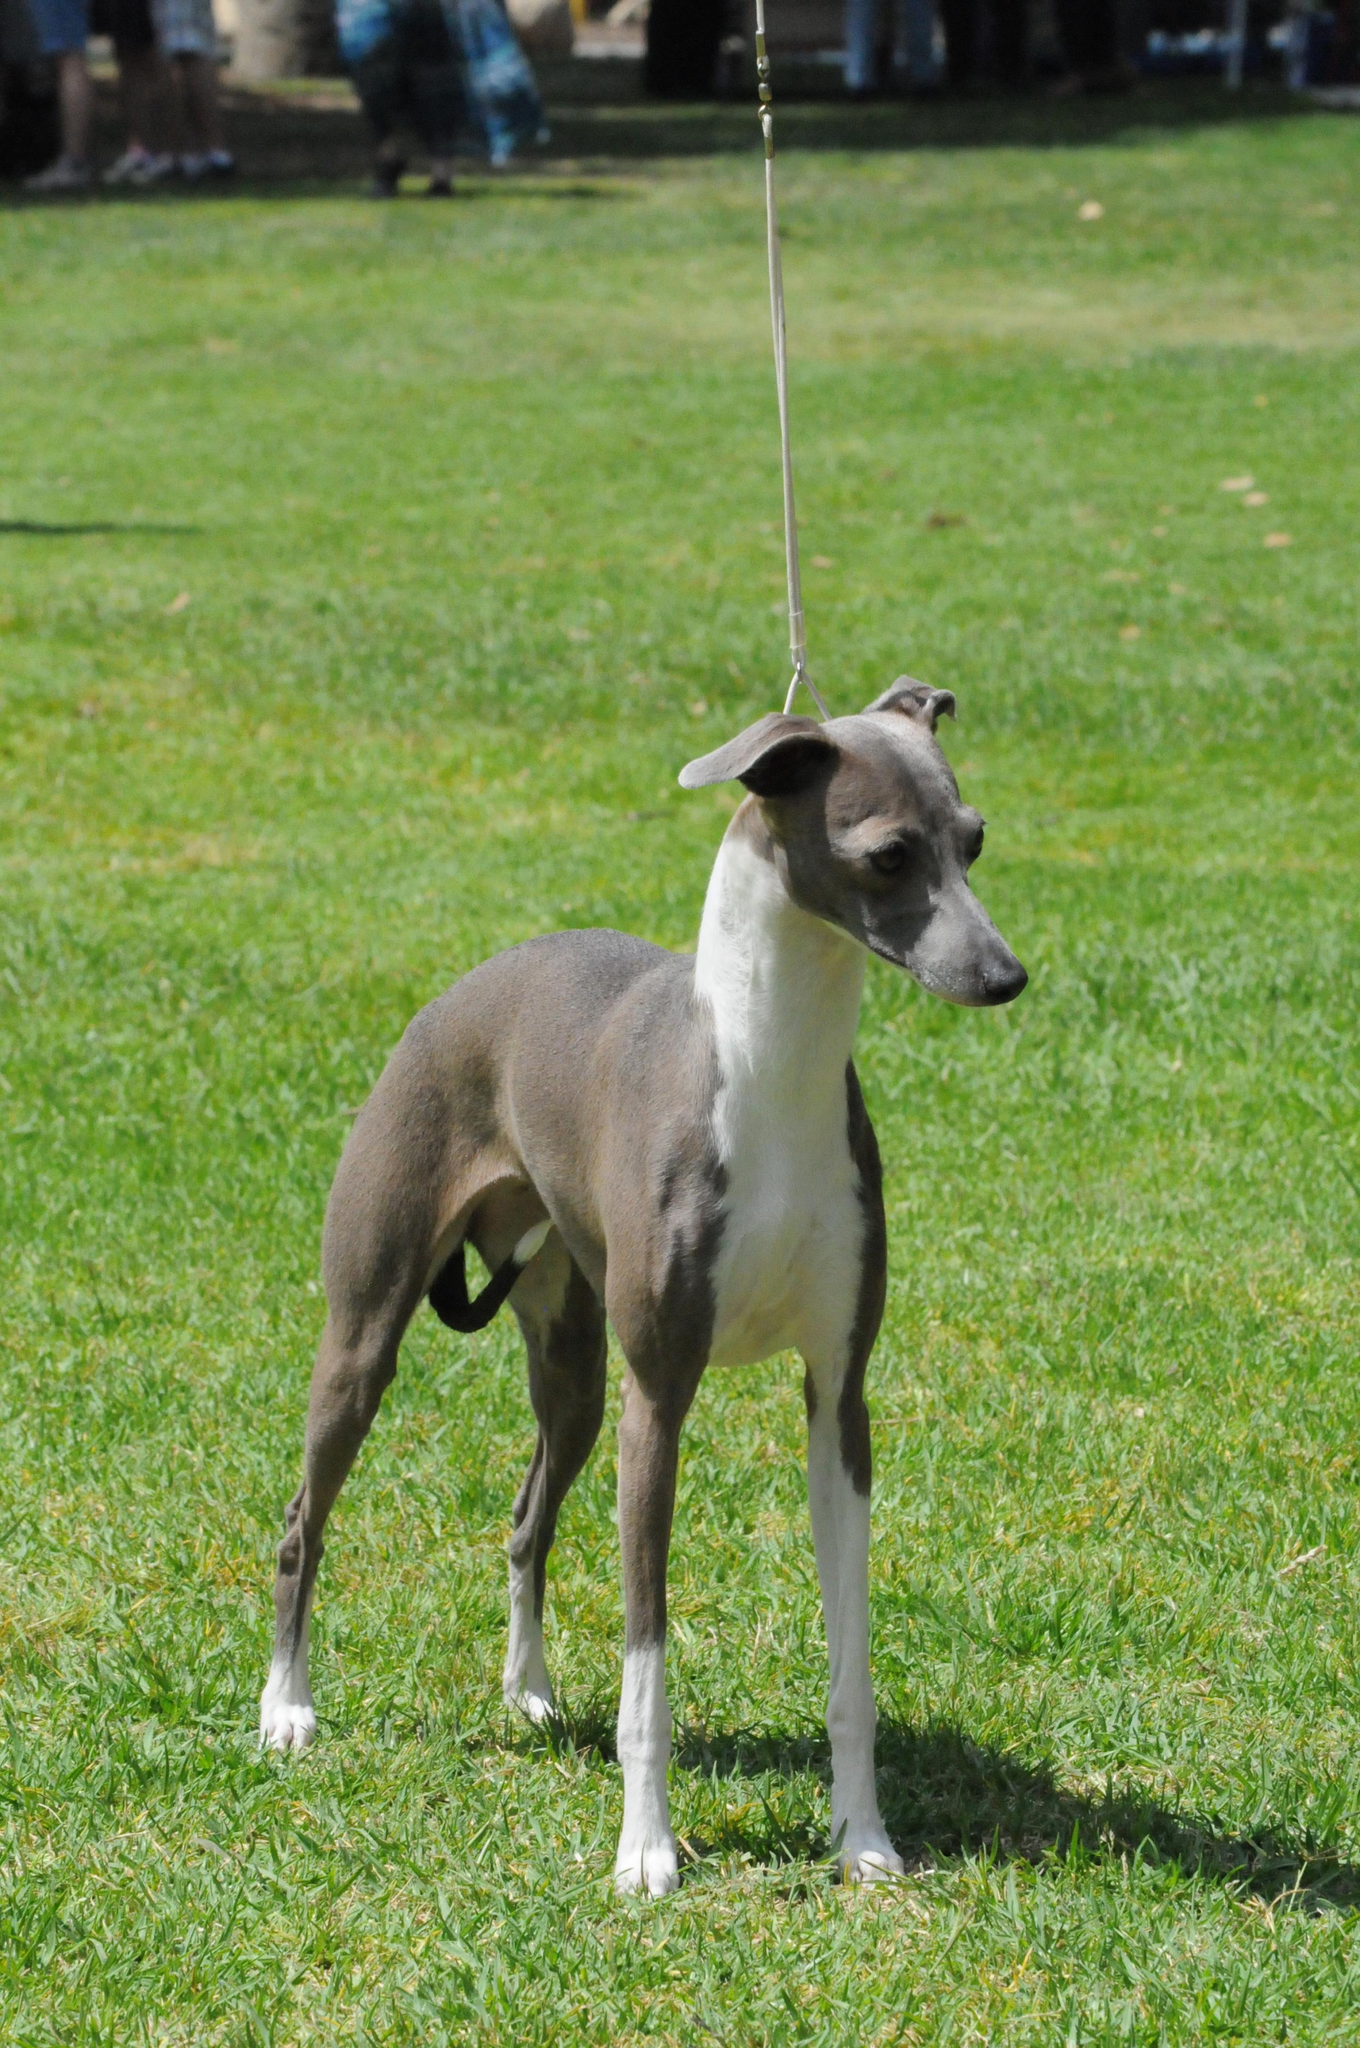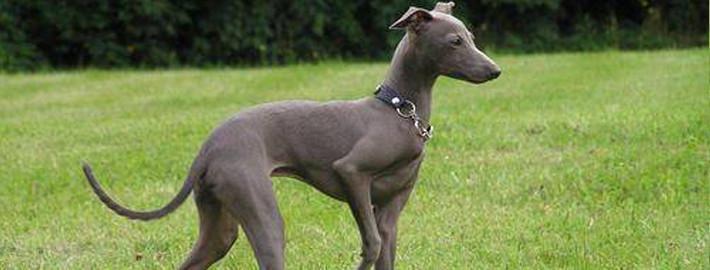The first image is the image on the left, the second image is the image on the right. Assess this claim about the two images: "There is a dog with its head to the left and its tail to the right.". Correct or not? Answer yes or no. No. 